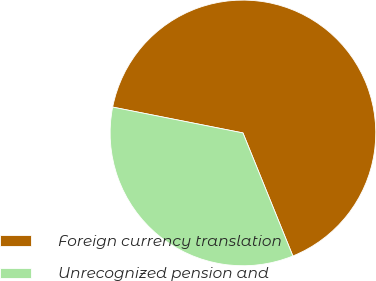Convert chart to OTSL. <chart><loc_0><loc_0><loc_500><loc_500><pie_chart><fcel>Foreign currency translation<fcel>Unrecognized pension and<nl><fcel>65.75%<fcel>34.25%<nl></chart> 